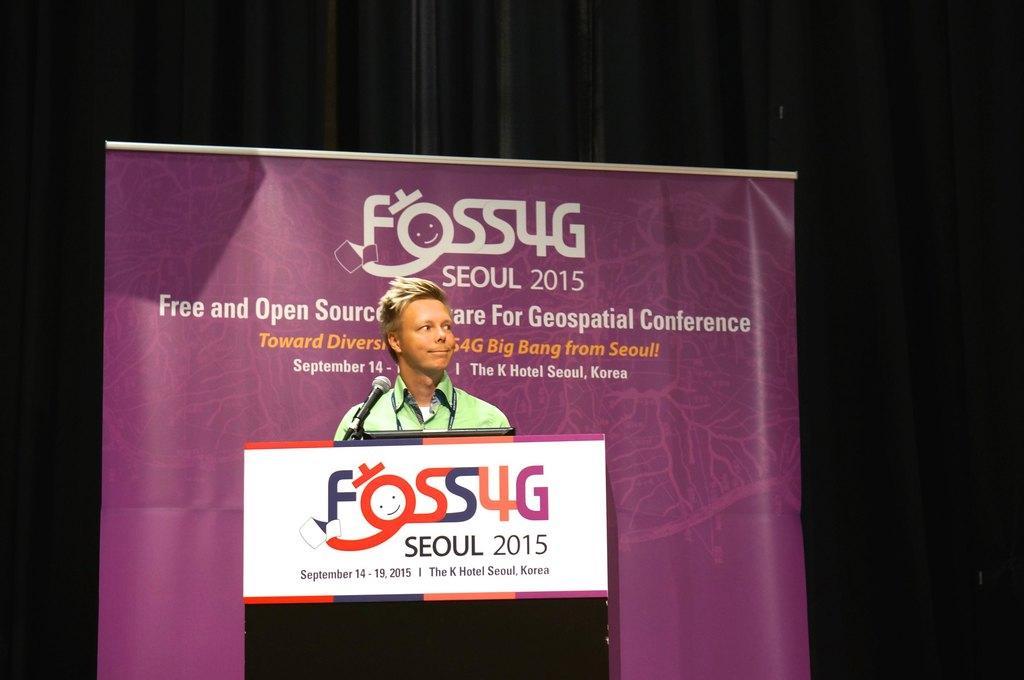In one or two sentences, can you explain what this image depicts? In this image we can see a person standing on the dais, in front of the person there is a mic, behind the person there is a banner. 